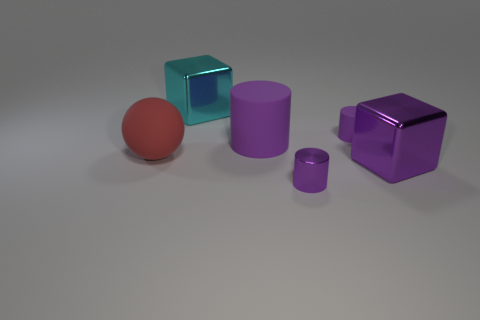Subtract 1 cylinders. How many cylinders are left? 2 Add 1 red matte spheres. How many objects exist? 7 Subtract all spheres. How many objects are left? 5 Add 4 purple things. How many purple things exist? 8 Subtract 0 yellow cylinders. How many objects are left? 6 Subtract all large brown blocks. Subtract all purple metal cylinders. How many objects are left? 5 Add 4 purple matte cylinders. How many purple matte cylinders are left? 6 